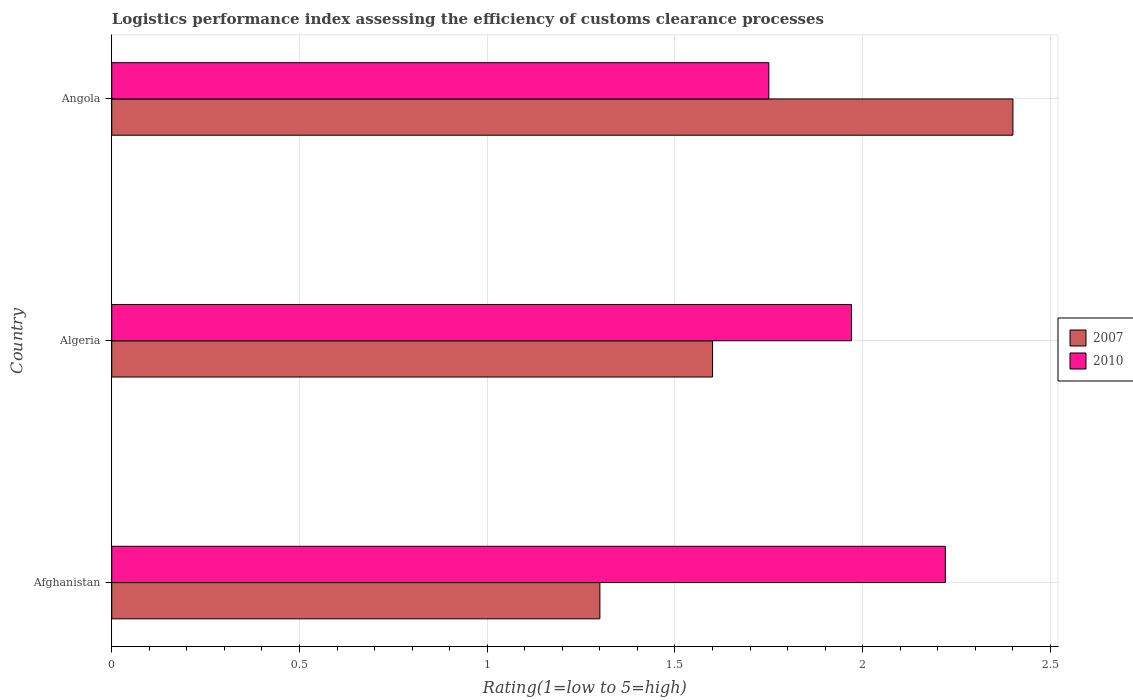How many groups of bars are there?
Your response must be concise. 3. Are the number of bars on each tick of the Y-axis equal?
Your response must be concise. Yes. How many bars are there on the 3rd tick from the bottom?
Keep it short and to the point. 2. What is the label of the 2nd group of bars from the top?
Keep it short and to the point. Algeria. What is the Logistic performance index in 2010 in Algeria?
Offer a terse response. 1.97. Across all countries, what is the maximum Logistic performance index in 2010?
Your response must be concise. 2.22. In which country was the Logistic performance index in 2010 maximum?
Keep it short and to the point. Afghanistan. In which country was the Logistic performance index in 2007 minimum?
Keep it short and to the point. Afghanistan. What is the total Logistic performance index in 2007 in the graph?
Your response must be concise. 5.3. What is the difference between the Logistic performance index in 2007 in Afghanistan and that in Angola?
Offer a terse response. -1.1. What is the difference between the Logistic performance index in 2010 in Angola and the Logistic performance index in 2007 in Algeria?
Ensure brevity in your answer.  0.15. What is the average Logistic performance index in 2007 per country?
Offer a very short reply. 1.77. What is the difference between the Logistic performance index in 2007 and Logistic performance index in 2010 in Angola?
Provide a short and direct response. 0.65. In how many countries, is the Logistic performance index in 2010 greater than 1.9 ?
Your answer should be very brief. 2. What is the ratio of the Logistic performance index in 2010 in Afghanistan to that in Algeria?
Provide a succinct answer. 1.13. Is the difference between the Logistic performance index in 2007 in Afghanistan and Algeria greater than the difference between the Logistic performance index in 2010 in Afghanistan and Algeria?
Give a very brief answer. No. What is the difference between the highest and the second highest Logistic performance index in 2007?
Make the answer very short. 0.8. What is the difference between the highest and the lowest Logistic performance index in 2007?
Ensure brevity in your answer.  1.1. In how many countries, is the Logistic performance index in 2010 greater than the average Logistic performance index in 2010 taken over all countries?
Your answer should be very brief. 1. What is the difference between two consecutive major ticks on the X-axis?
Your answer should be very brief. 0.5. Does the graph contain grids?
Provide a succinct answer. Yes. Where does the legend appear in the graph?
Your response must be concise. Center right. How are the legend labels stacked?
Your answer should be very brief. Vertical. What is the title of the graph?
Offer a terse response. Logistics performance index assessing the efficiency of customs clearance processes. What is the label or title of the X-axis?
Offer a terse response. Rating(1=low to 5=high). What is the Rating(1=low to 5=high) in 2010 in Afghanistan?
Keep it short and to the point. 2.22. What is the Rating(1=low to 5=high) of 2010 in Algeria?
Make the answer very short. 1.97. What is the Rating(1=low to 5=high) of 2010 in Angola?
Give a very brief answer. 1.75. Across all countries, what is the maximum Rating(1=low to 5=high) in 2007?
Offer a very short reply. 2.4. Across all countries, what is the maximum Rating(1=low to 5=high) in 2010?
Ensure brevity in your answer.  2.22. Across all countries, what is the minimum Rating(1=low to 5=high) of 2007?
Ensure brevity in your answer.  1.3. What is the total Rating(1=low to 5=high) in 2007 in the graph?
Your response must be concise. 5.3. What is the total Rating(1=low to 5=high) in 2010 in the graph?
Offer a very short reply. 5.94. What is the difference between the Rating(1=low to 5=high) of 2007 in Afghanistan and that in Angola?
Provide a short and direct response. -1.1. What is the difference between the Rating(1=low to 5=high) in 2010 in Afghanistan and that in Angola?
Make the answer very short. 0.47. What is the difference between the Rating(1=low to 5=high) of 2007 in Algeria and that in Angola?
Provide a short and direct response. -0.8. What is the difference between the Rating(1=low to 5=high) in 2010 in Algeria and that in Angola?
Keep it short and to the point. 0.22. What is the difference between the Rating(1=low to 5=high) in 2007 in Afghanistan and the Rating(1=low to 5=high) in 2010 in Algeria?
Make the answer very short. -0.67. What is the difference between the Rating(1=low to 5=high) of 2007 in Afghanistan and the Rating(1=low to 5=high) of 2010 in Angola?
Give a very brief answer. -0.45. What is the average Rating(1=low to 5=high) of 2007 per country?
Offer a terse response. 1.77. What is the average Rating(1=low to 5=high) of 2010 per country?
Your answer should be very brief. 1.98. What is the difference between the Rating(1=low to 5=high) in 2007 and Rating(1=low to 5=high) in 2010 in Afghanistan?
Give a very brief answer. -0.92. What is the difference between the Rating(1=low to 5=high) of 2007 and Rating(1=low to 5=high) of 2010 in Algeria?
Make the answer very short. -0.37. What is the difference between the Rating(1=low to 5=high) of 2007 and Rating(1=low to 5=high) of 2010 in Angola?
Provide a short and direct response. 0.65. What is the ratio of the Rating(1=low to 5=high) of 2007 in Afghanistan to that in Algeria?
Provide a short and direct response. 0.81. What is the ratio of the Rating(1=low to 5=high) of 2010 in Afghanistan to that in Algeria?
Ensure brevity in your answer.  1.13. What is the ratio of the Rating(1=low to 5=high) of 2007 in Afghanistan to that in Angola?
Offer a terse response. 0.54. What is the ratio of the Rating(1=low to 5=high) of 2010 in Afghanistan to that in Angola?
Your answer should be very brief. 1.27. What is the ratio of the Rating(1=low to 5=high) in 2010 in Algeria to that in Angola?
Give a very brief answer. 1.13. What is the difference between the highest and the second highest Rating(1=low to 5=high) of 2007?
Provide a succinct answer. 0.8. What is the difference between the highest and the second highest Rating(1=low to 5=high) in 2010?
Your response must be concise. 0.25. What is the difference between the highest and the lowest Rating(1=low to 5=high) of 2010?
Keep it short and to the point. 0.47. 